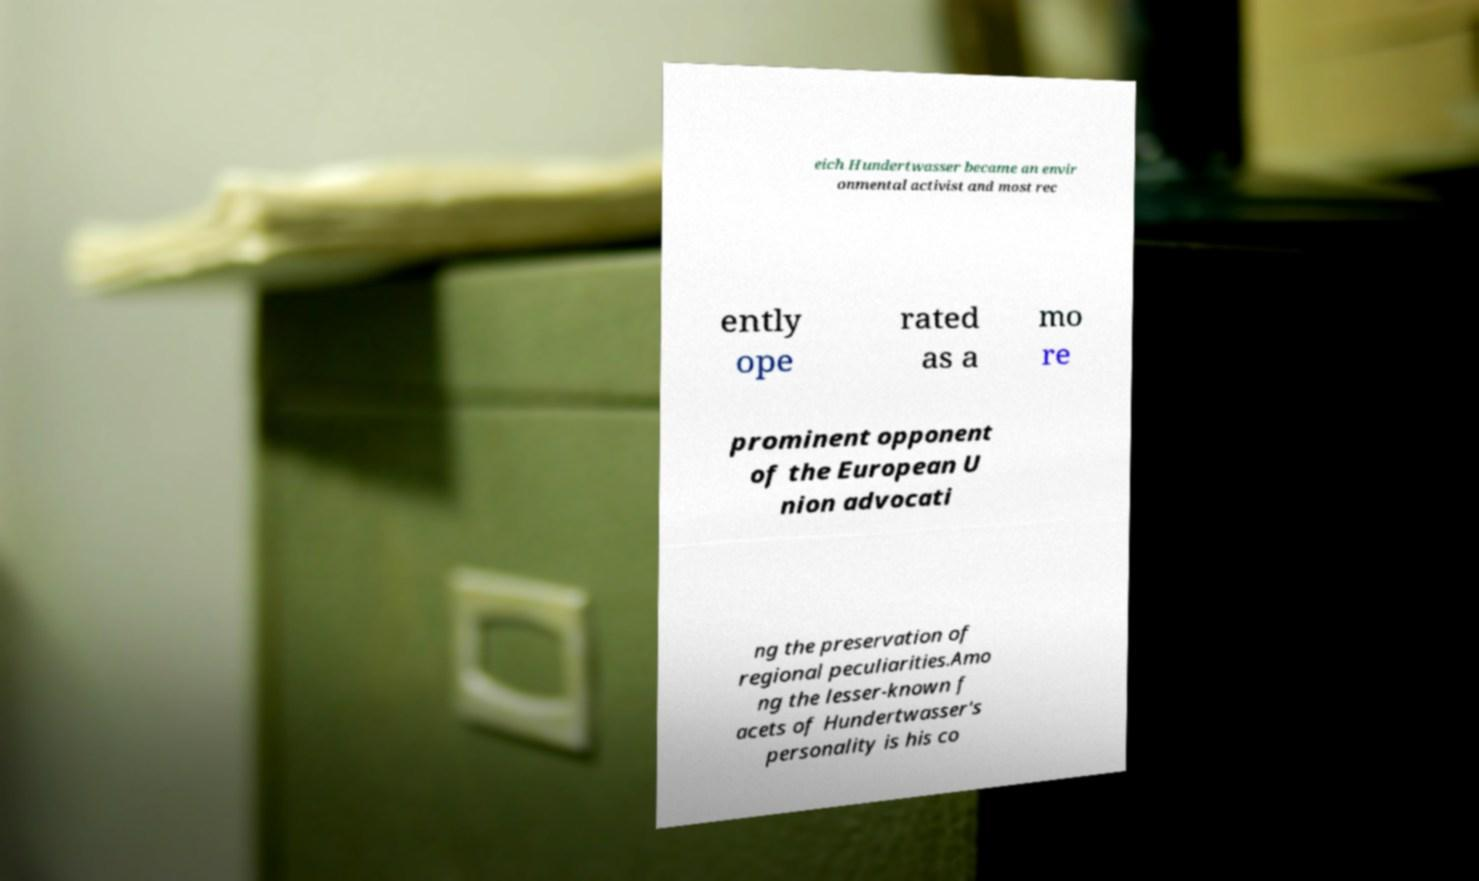For documentation purposes, I need the text within this image transcribed. Could you provide that? eich Hundertwasser became an envir onmental activist and most rec ently ope rated as a mo re prominent opponent of the European U nion advocati ng the preservation of regional peculiarities.Amo ng the lesser-known f acets of Hundertwasser's personality is his co 